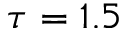<formula> <loc_0><loc_0><loc_500><loc_500>\tau = 1 . 5</formula> 